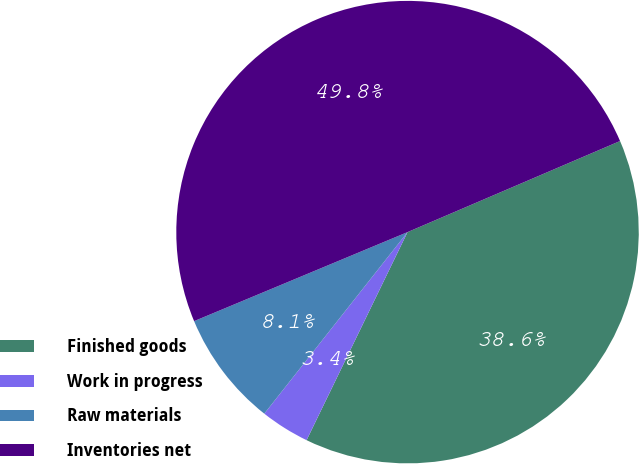<chart> <loc_0><loc_0><loc_500><loc_500><pie_chart><fcel>Finished goods<fcel>Work in progress<fcel>Raw materials<fcel>Inventories net<nl><fcel>38.63%<fcel>3.44%<fcel>8.08%<fcel>49.84%<nl></chart> 